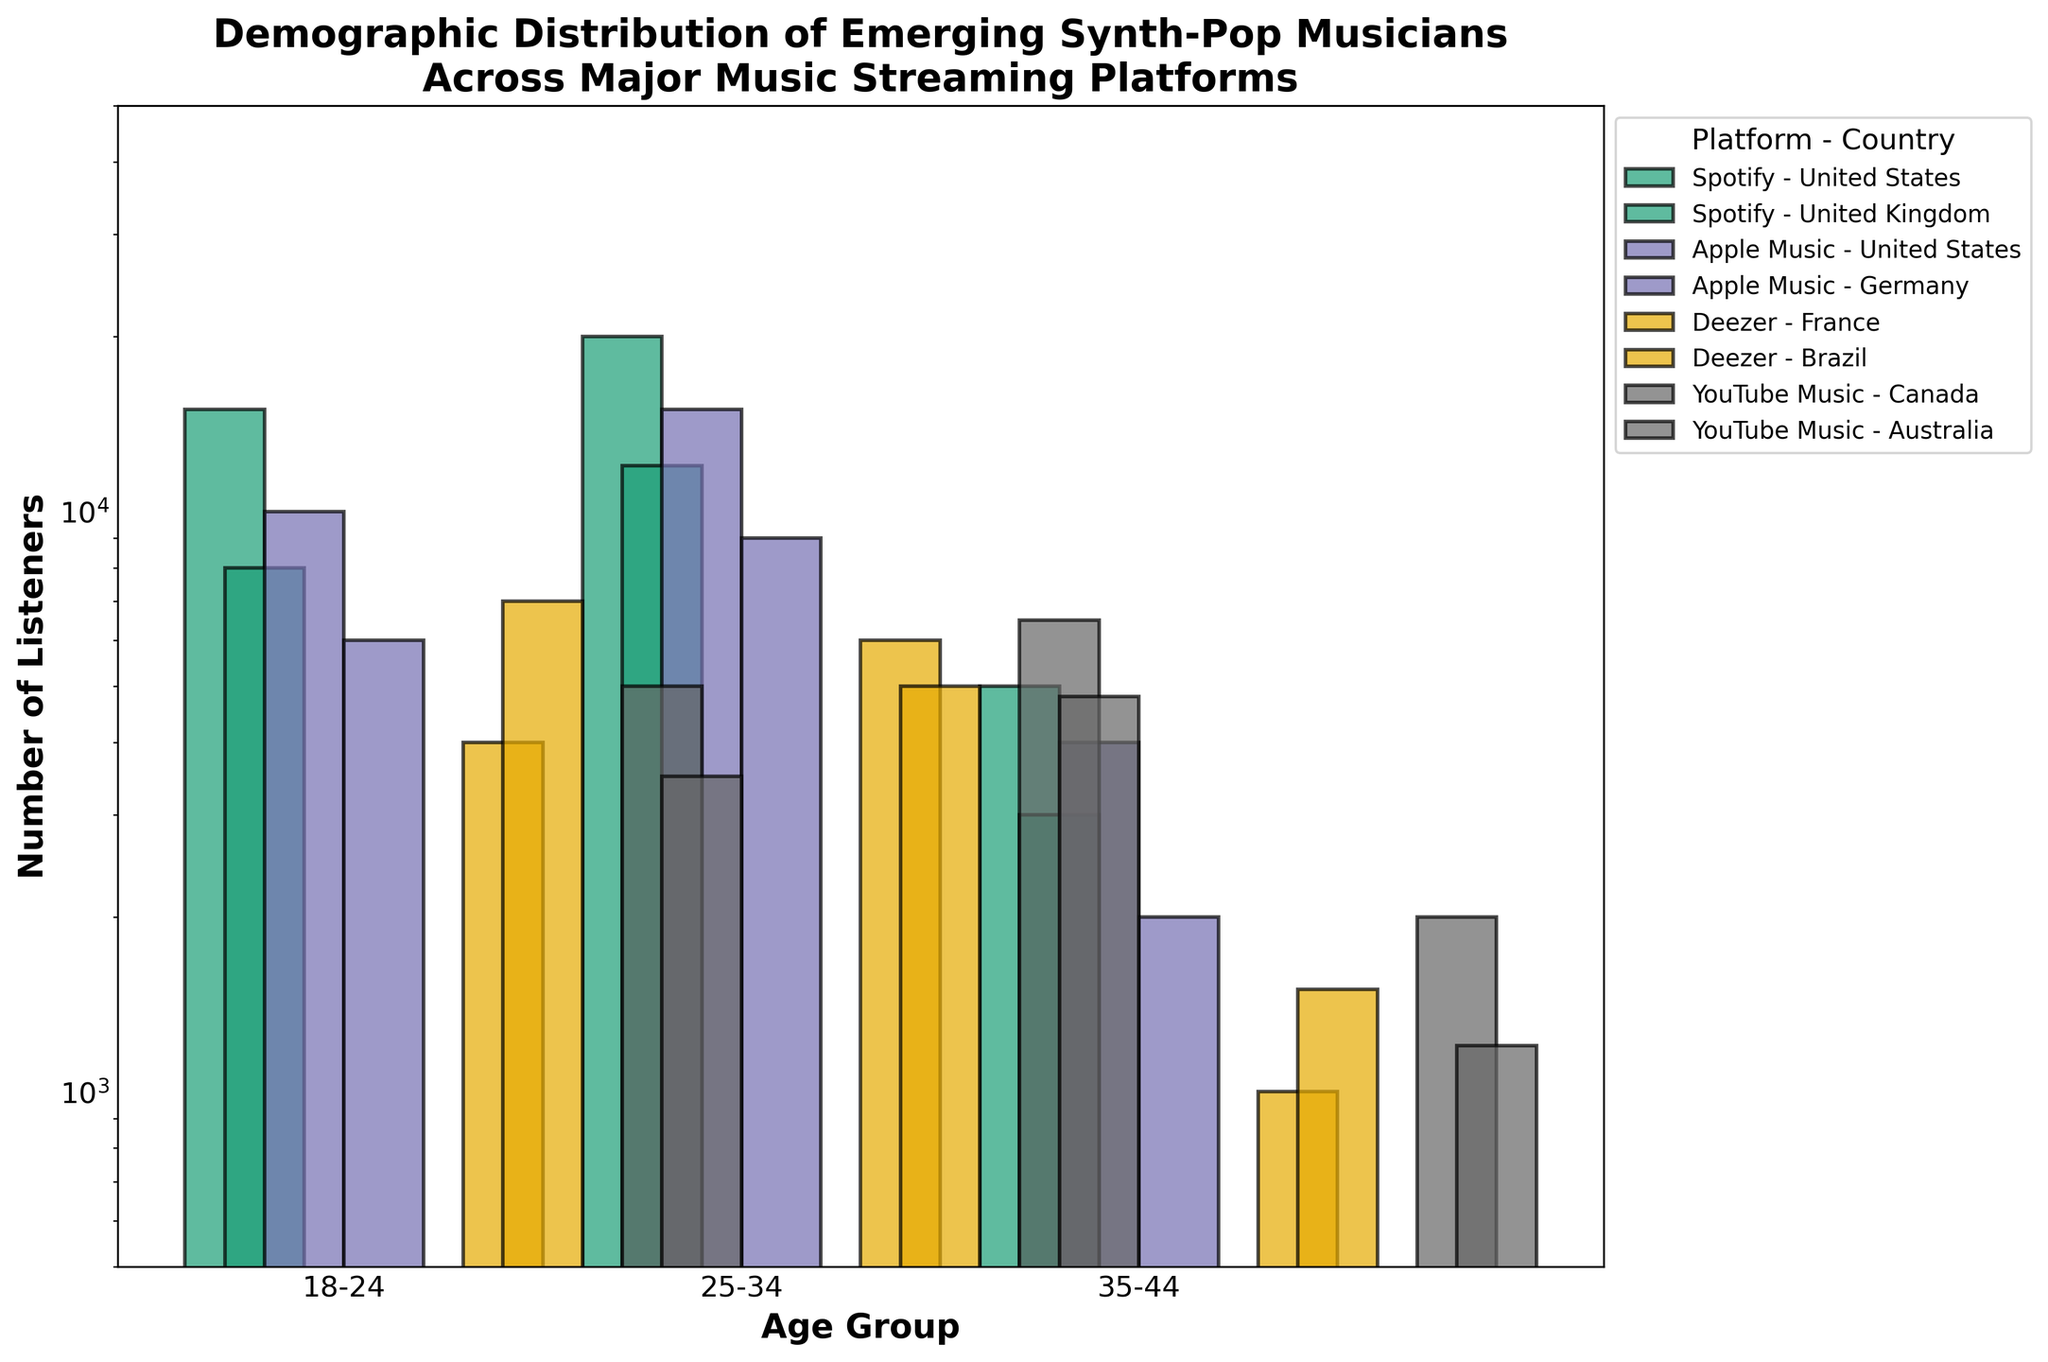What is the title of the figure? The title is located at the top-center of the figure and provides an overarching description of what the plot represents.
Answer: Demographic Distribution of Emerging Synth-Pop Musicians Across Major Music Streaming Platforms How is the y-axis labeled? The label is shown vertically along the y-axis. It provides information about what is being measured.
Answer: Number of Listeners How many age groups are represented in the figure? Count the tick labels on the x-axis, which represent different age groups.
Answer: 3 Which country on Spotify has the largest number of listeners in the 25-34 age group? Locate the bars representing Spotify in each country for the 25-34 age group and compare their heights (or y-values in log scale).
Answer: United States What is the approximate number of listeners for YouTube Music in Canada for the 35-44 age group? Find the bar corresponding to YouTube Music in Canada for the 35-44 age group and estimate its height on the log scale.
Answer: 2000 What is the combined total of listeners for the 18-24 age group on Deezer in France and Brazil? Identify the two bars representing Deezer for the 18-24 age group in France and Brazil, and sum their values. France: 4000, Brazil: 7000. 4000 + 7000 = 11000
Answer: 11000 Which platforms represent the largest and smallest number of listeners in the United States for the 35-44 age group? Compare the heights of the bars representing different platforms in the United States for the 35-44 age group to find the largest and smallest values.
Answer: Largest: Spotify, Smallest: Apple Music Which age group has the highest number of listeners across all platforms in Australia? Compare the bars across all platforms in Australia for the three age groups and identify the highest one.
Answer: 25-34 How does the number of listeners for Apple Music in Germany for the 18-24 age group compare to that in the 25-34 age group? Compare the heights of the two bars representing Apple Music in Germany for the 18-24 and 25-34 age groups.
Answer: 18-24 is smaller than 25-34 What is the range of the y-axis? Identify the minimum and maximum values displayed along the y-axis.
Answer: 500 to 50000 